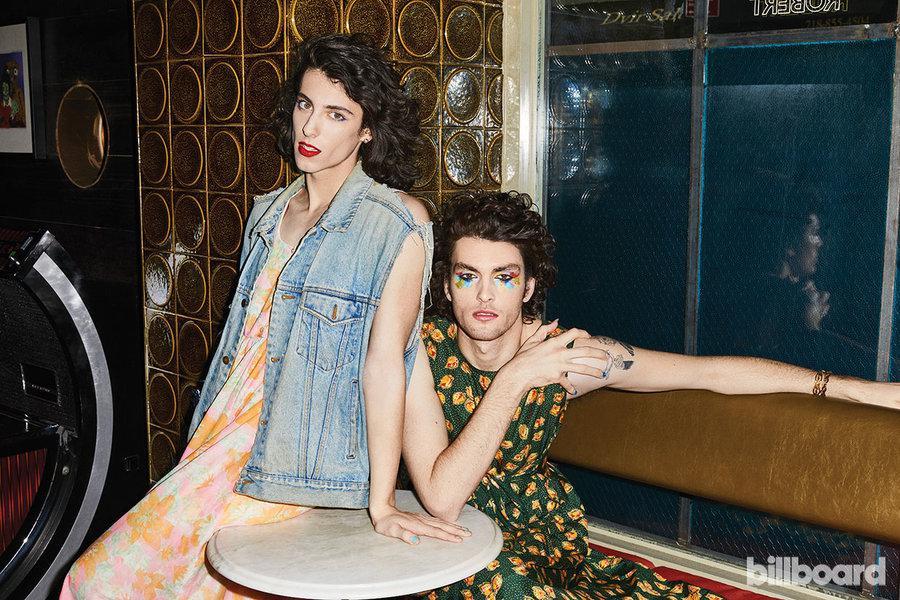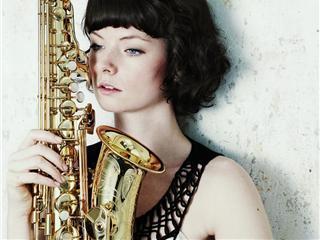The first image is the image on the left, the second image is the image on the right. Evaluate the accuracy of this statement regarding the images: "At least one woman appears to be actively playing a saxophone.". Is it true? Answer yes or no. No. 